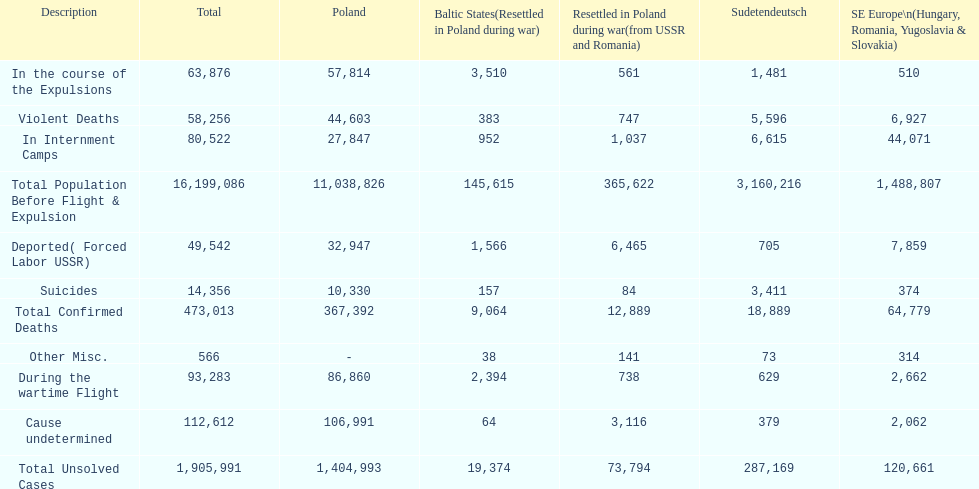Which region had the least total of unsolved cases? Baltic States(Resettled in Poland during war). 